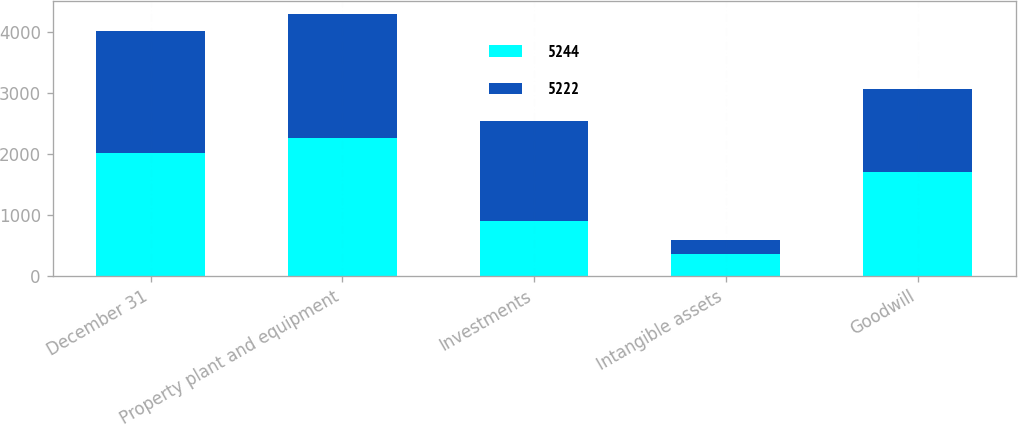Convert chart to OTSL. <chart><loc_0><loc_0><loc_500><loc_500><stacked_bar_chart><ecel><fcel>December 31<fcel>Property plant and equipment<fcel>Investments<fcel>Intangible assets<fcel>Goodwill<nl><fcel>5244<fcel>2006<fcel>2267<fcel>895<fcel>354<fcel>1706<nl><fcel>5222<fcel>2005<fcel>2020<fcel>1644<fcel>231<fcel>1349<nl></chart> 